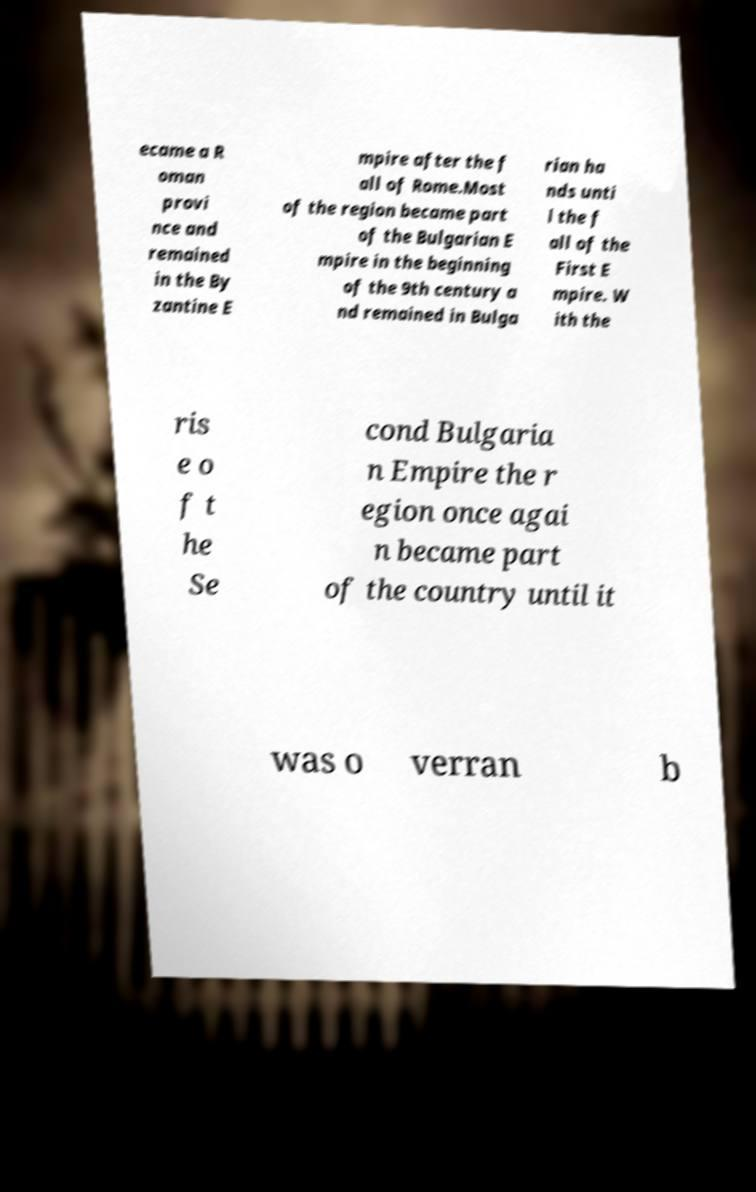Could you assist in decoding the text presented in this image and type it out clearly? ecame a R oman provi nce and remained in the By zantine E mpire after the f all of Rome.Most of the region became part of the Bulgarian E mpire in the beginning of the 9th century a nd remained in Bulga rian ha nds unti l the f all of the First E mpire. W ith the ris e o f t he Se cond Bulgaria n Empire the r egion once agai n became part of the country until it was o verran b 